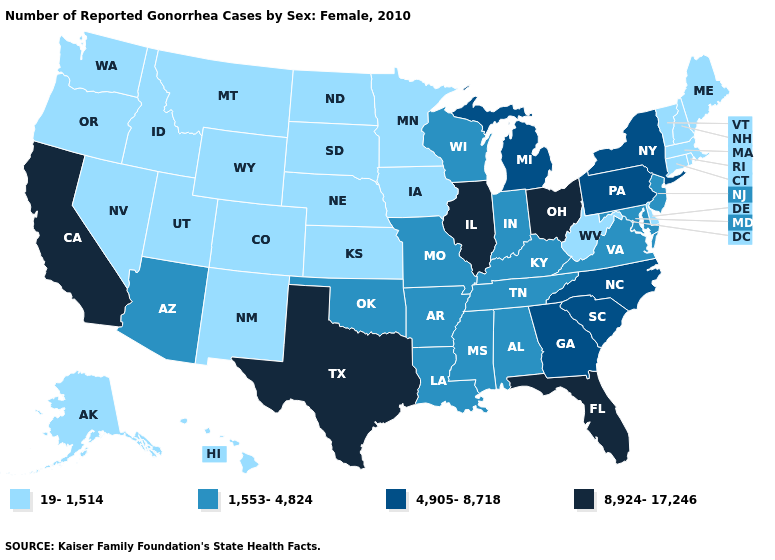Does Louisiana have the lowest value in the USA?
Give a very brief answer. No. Which states hav the highest value in the MidWest?
Be succinct. Illinois, Ohio. What is the value of Ohio?
Quick response, please. 8,924-17,246. Among the states that border Georgia , which have the highest value?
Keep it brief. Florida. Does Colorado have the lowest value in the USA?
Quick response, please. Yes. What is the value of North Dakota?
Concise answer only. 19-1,514. What is the value of Montana?
Short answer required. 19-1,514. What is the value of Kentucky?
Short answer required. 1,553-4,824. What is the highest value in the USA?
Keep it brief. 8,924-17,246. Name the states that have a value in the range 1,553-4,824?
Short answer required. Alabama, Arizona, Arkansas, Indiana, Kentucky, Louisiana, Maryland, Mississippi, Missouri, New Jersey, Oklahoma, Tennessee, Virginia, Wisconsin. What is the lowest value in the Northeast?
Short answer required. 19-1,514. What is the value of California?
Keep it brief. 8,924-17,246. What is the value of Michigan?
Quick response, please. 4,905-8,718. Among the states that border Maine , which have the highest value?
Be succinct. New Hampshire. Does Pennsylvania have the highest value in the Northeast?
Quick response, please. Yes. 